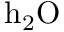<formula> <loc_0><loc_0><loc_500><loc_500>{ h } _ { 2 } O</formula> 